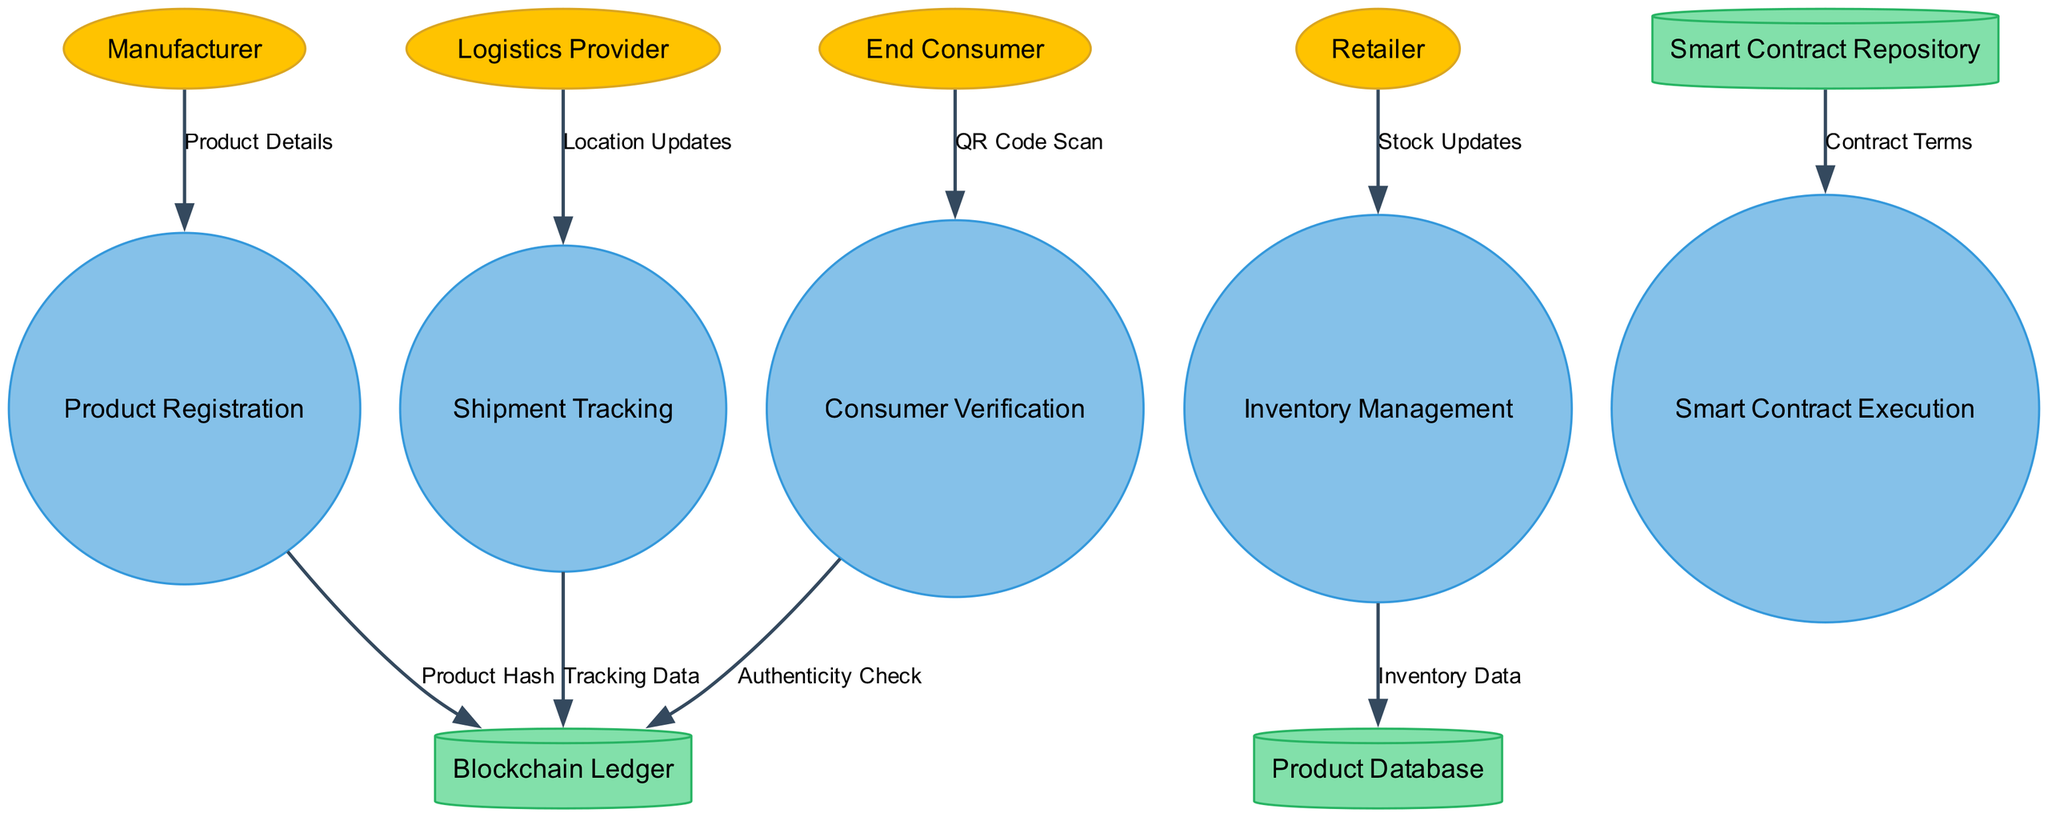What external entities are involved in the supply chain? The diagram lists four external entities: Manufacturer, Logistics Provider, Retailer, and End Consumer.
Answer: Manufacturer, Logistics Provider, Retailer, End Consumer How many processes are included in the diagram? There are five processes depicted in the diagram: Product Registration, Shipment Tracking, Inventory Management, Smart Contract Execution, and Consumer Verification.
Answer: Five What data flow comes from the Logistics Provider? The data flow from the Logistics Provider is labeled "Location Updates" and goes to the Shipment Tracking process.
Answer: Location Updates Which data store receives data from Inventory Management? The Inventory Management process sends data labeled "Inventory Data" to the Product Database.
Answer: Product Database What type of data is sent to the Blockchain Ledger from Shipment Tracking? The data flow from Shipment Tracking to the Blockchain Ledger is labeled "Tracking Data."
Answer: Tracking Data What is the primary purpose of the Consumer Verification process? The Consumer Verification process receives a "QR Code Scan" from the End Consumer to check authenticity.
Answer: Authenticity Check How does product registration contribute to the Blockchain Ledger? The Product Registration process sends "Product Hash" data to the Blockchain Ledger, thus contributing to its integrity and traceability.
Answer: Product Hash What does the Smart Contract Repository provide to the Smart Contract Execution process? The Smart Contract Repository provides "Contract Terms," which are the conditions under which smart contracts are executed.
Answer: Contract Terms How many data stores are identified in the diagram? There are three data stores in the diagram: Blockchain Ledger, Product Database, and Smart Contract Repository.
Answer: Three 